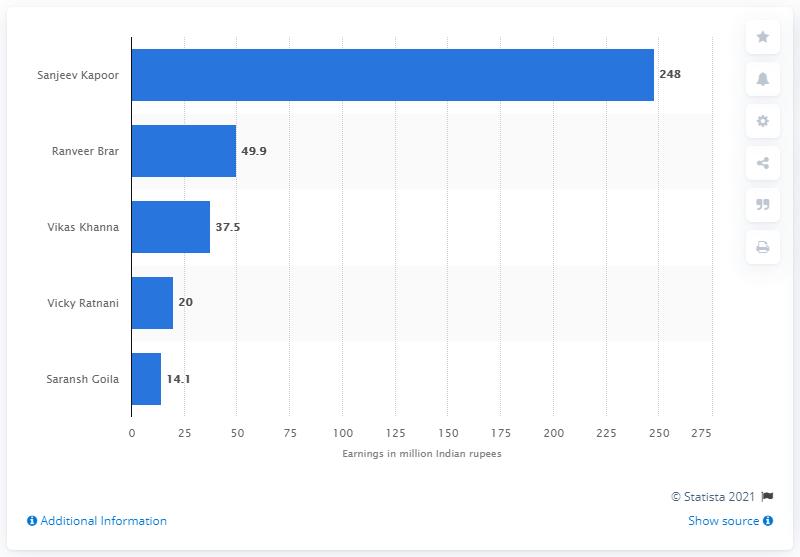Outline some significant characteristics in this image. Sanjeev Kapoor was the best-paid chef in India in 2019. 